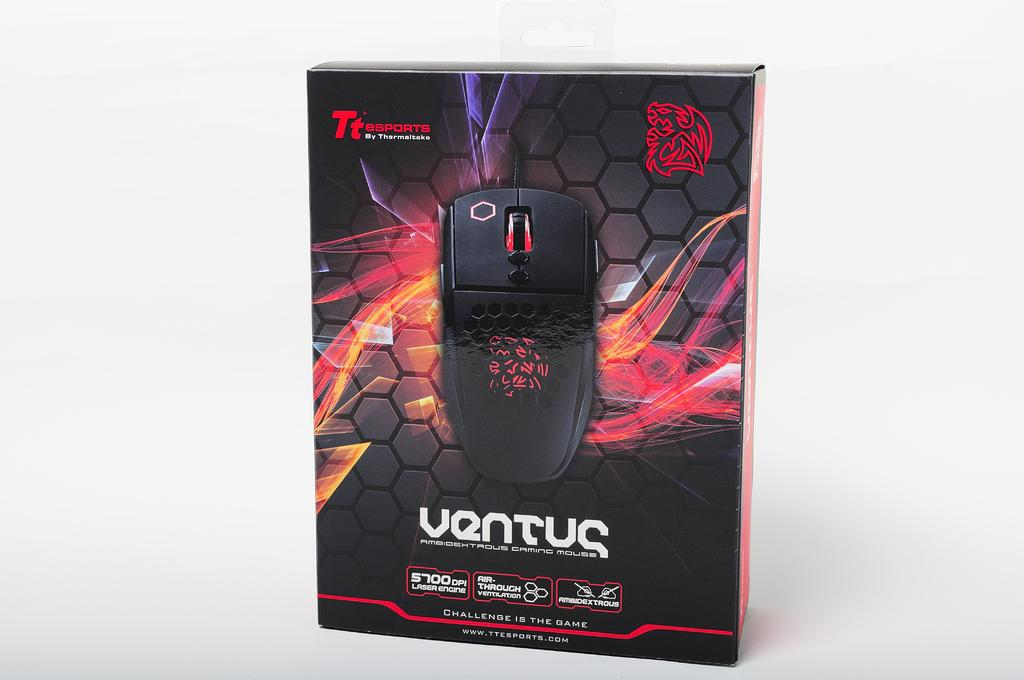What is the main subject in the center of the image? There is a box in the center of the image. What is depicted on the box? There is a photo of a mouse on the box. How many women are depicted in the image? There are no women depicted in the image; it features a photo of a mouse on a box. What type of industry is shown in the image? There is no industry depicted in the image; it features a photo of a mouse on a box. 